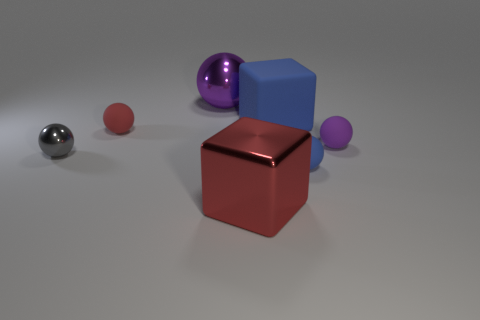Subtract 1 spheres. How many spheres are left? 4 Subtract all tiny blue matte balls. How many balls are left? 4 Subtract all cyan spheres. Subtract all cyan cubes. How many spheres are left? 5 Add 3 gray spheres. How many objects exist? 10 Subtract all spheres. How many objects are left? 2 Subtract all large red blocks. Subtract all large red metal cubes. How many objects are left? 5 Add 7 rubber spheres. How many rubber spheres are left? 10 Add 3 big green cubes. How many big green cubes exist? 3 Subtract 0 green blocks. How many objects are left? 7 